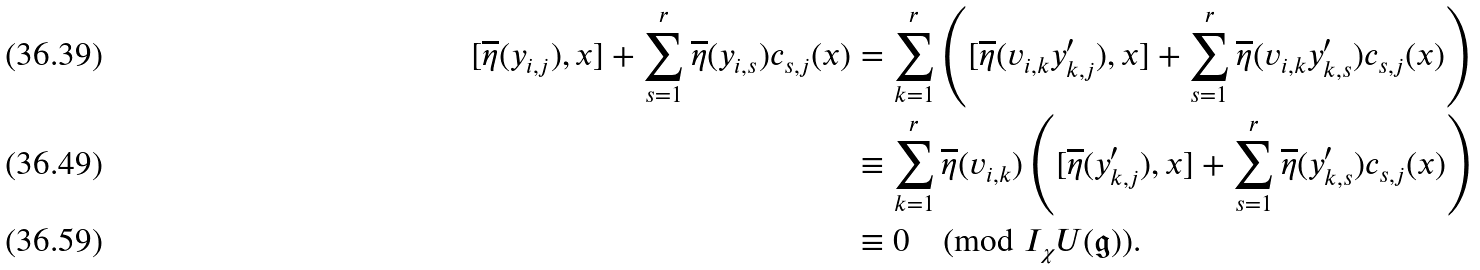Convert formula to latex. <formula><loc_0><loc_0><loc_500><loc_500>[ \overline { \eta } ( y _ { i , j } ) , x ] + \sum _ { s = 1 } ^ { r } \overline { \eta } ( y _ { i , s } ) c _ { s , j } ( x ) & = \sum _ { k = 1 } ^ { r } \left ( [ \overline { \eta } ( { v } _ { i , k } y _ { k , j } ^ { \prime } ) , x ] + \sum _ { s = 1 } ^ { r } \overline { \eta } ( v _ { i , k } y _ { k , s } ^ { \prime } ) c _ { s , j } ( x ) \right ) \\ & \equiv \sum _ { k = 1 } ^ { r } \overline { \eta } ( { v } _ { i , k } ) \left ( [ \overline { \eta } ( y _ { k , j } ^ { \prime } ) , x ] + \sum _ { s = 1 } ^ { r } \overline { \eta } ( y _ { k , s } ^ { \prime } ) c _ { s , j } ( x ) \right ) \\ & \equiv 0 \pmod { I _ { \chi } U ( \mathfrak { g } ) } .</formula> 